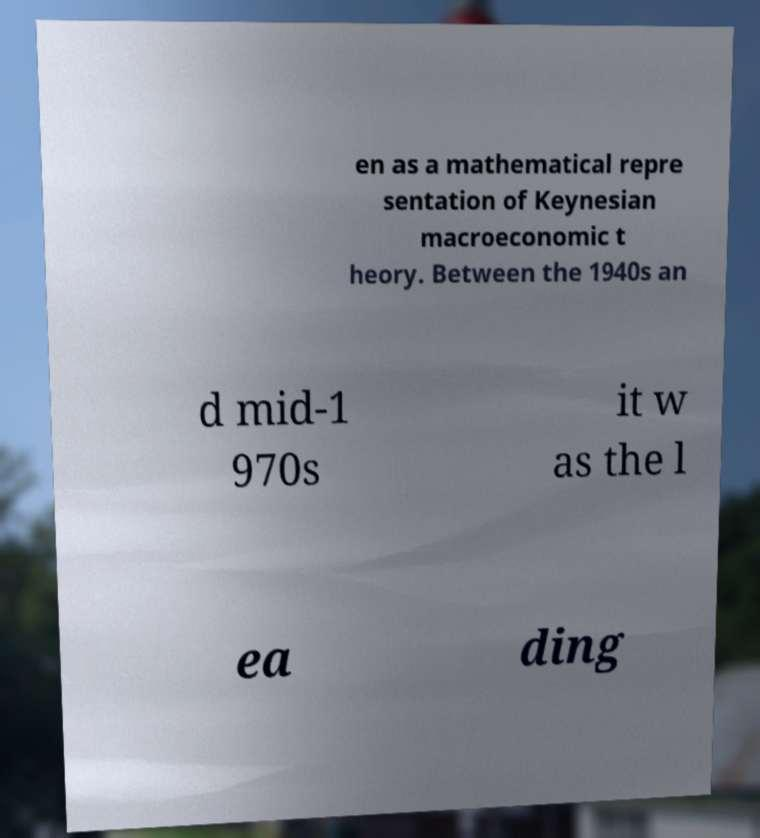Can you accurately transcribe the text from the provided image for me? en as a mathematical repre sentation of Keynesian macroeconomic t heory. Between the 1940s an d mid-1 970s it w as the l ea ding 